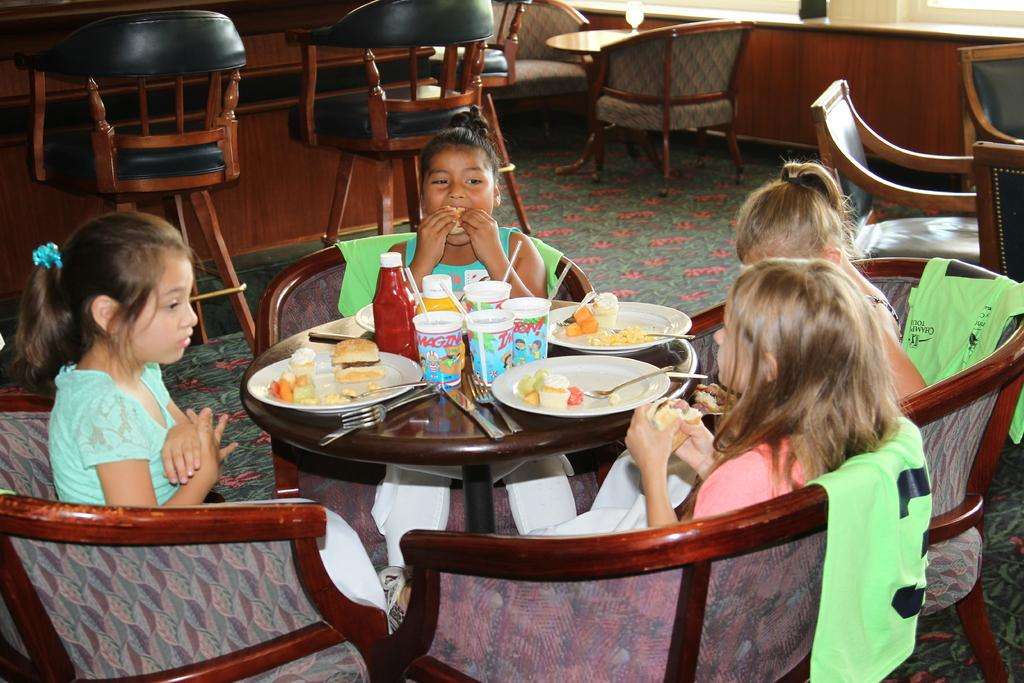How many kids are present in the image? There are four kids in the image. What are the kids doing in the image? The kids are sitting on chairs in the image. How are the chairs arranged in the image? The chairs are arranged around a table in the image. What is on the table in the image? There is a plate with food, forks and knives, and soft drinks on the table in the image. What is on the floor in the image? There is a carpet on the floor in the image. What type of sign can be seen on the wall in the image? There is no sign visible on the wall in the image. What show are the kids watching on the television in the image? There is no television present in the image; the kids are sitting around a table with food and drinks. 